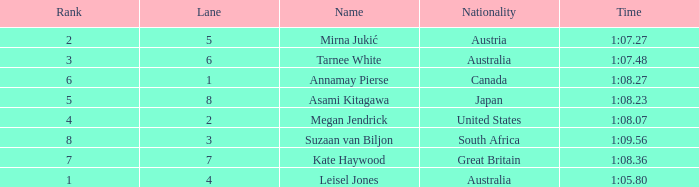What is the Nationality of the Swimmer in Lane 4 or larger with a Rank of 5 or more? Great Britain. 